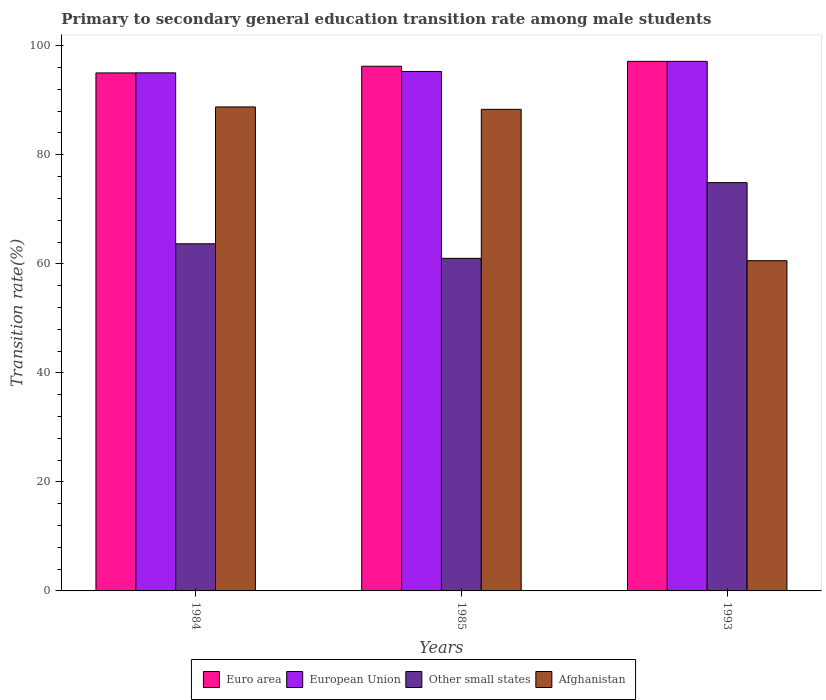How many groups of bars are there?
Your answer should be very brief. 3. In how many cases, is the number of bars for a given year not equal to the number of legend labels?
Your response must be concise. 0. What is the transition rate in Euro area in 1984?
Ensure brevity in your answer.  95.02. Across all years, what is the maximum transition rate in Other small states?
Offer a very short reply. 74.9. Across all years, what is the minimum transition rate in Euro area?
Ensure brevity in your answer.  95.02. In which year was the transition rate in Other small states maximum?
Offer a terse response. 1993. In which year was the transition rate in Other small states minimum?
Ensure brevity in your answer.  1985. What is the total transition rate in Afghanistan in the graph?
Give a very brief answer. 237.69. What is the difference between the transition rate in European Union in 1985 and that in 1993?
Provide a succinct answer. -1.85. What is the difference between the transition rate in Other small states in 1993 and the transition rate in European Union in 1984?
Make the answer very short. -20.14. What is the average transition rate in European Union per year?
Your answer should be compact. 95.82. In the year 1993, what is the difference between the transition rate in Afghanistan and transition rate in European Union?
Your answer should be compact. -36.57. What is the ratio of the transition rate in European Union in 1984 to that in 1993?
Keep it short and to the point. 0.98. Is the difference between the transition rate in Afghanistan in 1985 and 1993 greater than the difference between the transition rate in European Union in 1985 and 1993?
Provide a succinct answer. Yes. What is the difference between the highest and the second highest transition rate in Other small states?
Provide a short and direct response. 11.22. What is the difference between the highest and the lowest transition rate in Other small states?
Provide a short and direct response. 13.89. What does the 3rd bar from the left in 1984 represents?
Your answer should be very brief. Other small states. How many years are there in the graph?
Your response must be concise. 3. What is the difference between two consecutive major ticks on the Y-axis?
Offer a very short reply. 20. Does the graph contain any zero values?
Offer a terse response. No. What is the title of the graph?
Ensure brevity in your answer.  Primary to secondary general education transition rate among male students. What is the label or title of the Y-axis?
Provide a succinct answer. Transition rate(%). What is the Transition rate(%) of Euro area in 1984?
Give a very brief answer. 95.02. What is the Transition rate(%) in European Union in 1984?
Give a very brief answer. 95.03. What is the Transition rate(%) in Other small states in 1984?
Give a very brief answer. 63.68. What is the Transition rate(%) of Afghanistan in 1984?
Make the answer very short. 88.78. What is the Transition rate(%) of Euro area in 1985?
Provide a succinct answer. 96.24. What is the Transition rate(%) of European Union in 1985?
Keep it short and to the point. 95.29. What is the Transition rate(%) of Other small states in 1985?
Give a very brief answer. 61. What is the Transition rate(%) of Afghanistan in 1985?
Ensure brevity in your answer.  88.34. What is the Transition rate(%) of Euro area in 1993?
Your response must be concise. 97.14. What is the Transition rate(%) of European Union in 1993?
Your answer should be very brief. 97.14. What is the Transition rate(%) of Other small states in 1993?
Offer a terse response. 74.9. What is the Transition rate(%) of Afghanistan in 1993?
Offer a terse response. 60.58. Across all years, what is the maximum Transition rate(%) in Euro area?
Ensure brevity in your answer.  97.14. Across all years, what is the maximum Transition rate(%) in European Union?
Your response must be concise. 97.14. Across all years, what is the maximum Transition rate(%) in Other small states?
Your response must be concise. 74.9. Across all years, what is the maximum Transition rate(%) of Afghanistan?
Offer a terse response. 88.78. Across all years, what is the minimum Transition rate(%) in Euro area?
Your answer should be compact. 95.02. Across all years, what is the minimum Transition rate(%) of European Union?
Make the answer very short. 95.03. Across all years, what is the minimum Transition rate(%) in Other small states?
Make the answer very short. 61. Across all years, what is the minimum Transition rate(%) of Afghanistan?
Make the answer very short. 60.58. What is the total Transition rate(%) in Euro area in the graph?
Your answer should be compact. 288.4. What is the total Transition rate(%) of European Union in the graph?
Offer a very short reply. 287.46. What is the total Transition rate(%) in Other small states in the graph?
Ensure brevity in your answer.  199.58. What is the total Transition rate(%) in Afghanistan in the graph?
Offer a terse response. 237.69. What is the difference between the Transition rate(%) in Euro area in 1984 and that in 1985?
Provide a short and direct response. -1.22. What is the difference between the Transition rate(%) of European Union in 1984 and that in 1985?
Ensure brevity in your answer.  -0.25. What is the difference between the Transition rate(%) of Other small states in 1984 and that in 1985?
Offer a very short reply. 2.67. What is the difference between the Transition rate(%) in Afghanistan in 1984 and that in 1985?
Give a very brief answer. 0.44. What is the difference between the Transition rate(%) of Euro area in 1984 and that in 1993?
Provide a succinct answer. -2.12. What is the difference between the Transition rate(%) in European Union in 1984 and that in 1993?
Offer a very short reply. -2.11. What is the difference between the Transition rate(%) in Other small states in 1984 and that in 1993?
Provide a short and direct response. -11.22. What is the difference between the Transition rate(%) in Afghanistan in 1984 and that in 1993?
Keep it short and to the point. 28.2. What is the difference between the Transition rate(%) of Euro area in 1985 and that in 1993?
Give a very brief answer. -0.9. What is the difference between the Transition rate(%) of European Union in 1985 and that in 1993?
Your answer should be compact. -1.85. What is the difference between the Transition rate(%) in Other small states in 1985 and that in 1993?
Offer a very short reply. -13.89. What is the difference between the Transition rate(%) of Afghanistan in 1985 and that in 1993?
Ensure brevity in your answer.  27.76. What is the difference between the Transition rate(%) of Euro area in 1984 and the Transition rate(%) of European Union in 1985?
Your response must be concise. -0.27. What is the difference between the Transition rate(%) in Euro area in 1984 and the Transition rate(%) in Other small states in 1985?
Provide a short and direct response. 34.01. What is the difference between the Transition rate(%) of Euro area in 1984 and the Transition rate(%) of Afghanistan in 1985?
Offer a very short reply. 6.68. What is the difference between the Transition rate(%) of European Union in 1984 and the Transition rate(%) of Other small states in 1985?
Offer a terse response. 34.03. What is the difference between the Transition rate(%) in European Union in 1984 and the Transition rate(%) in Afghanistan in 1985?
Give a very brief answer. 6.69. What is the difference between the Transition rate(%) of Other small states in 1984 and the Transition rate(%) of Afghanistan in 1985?
Ensure brevity in your answer.  -24.66. What is the difference between the Transition rate(%) in Euro area in 1984 and the Transition rate(%) in European Union in 1993?
Provide a short and direct response. -2.12. What is the difference between the Transition rate(%) of Euro area in 1984 and the Transition rate(%) of Other small states in 1993?
Your answer should be compact. 20.12. What is the difference between the Transition rate(%) in Euro area in 1984 and the Transition rate(%) in Afghanistan in 1993?
Your response must be concise. 34.44. What is the difference between the Transition rate(%) of European Union in 1984 and the Transition rate(%) of Other small states in 1993?
Ensure brevity in your answer.  20.14. What is the difference between the Transition rate(%) in European Union in 1984 and the Transition rate(%) in Afghanistan in 1993?
Offer a very short reply. 34.46. What is the difference between the Transition rate(%) in Other small states in 1984 and the Transition rate(%) in Afghanistan in 1993?
Keep it short and to the point. 3.1. What is the difference between the Transition rate(%) of Euro area in 1985 and the Transition rate(%) of European Union in 1993?
Keep it short and to the point. -0.9. What is the difference between the Transition rate(%) in Euro area in 1985 and the Transition rate(%) in Other small states in 1993?
Provide a succinct answer. 21.34. What is the difference between the Transition rate(%) in Euro area in 1985 and the Transition rate(%) in Afghanistan in 1993?
Ensure brevity in your answer.  35.66. What is the difference between the Transition rate(%) of European Union in 1985 and the Transition rate(%) of Other small states in 1993?
Give a very brief answer. 20.39. What is the difference between the Transition rate(%) of European Union in 1985 and the Transition rate(%) of Afghanistan in 1993?
Offer a very short reply. 34.71. What is the difference between the Transition rate(%) of Other small states in 1985 and the Transition rate(%) of Afghanistan in 1993?
Your answer should be compact. 0.43. What is the average Transition rate(%) of Euro area per year?
Give a very brief answer. 96.13. What is the average Transition rate(%) in European Union per year?
Provide a short and direct response. 95.82. What is the average Transition rate(%) of Other small states per year?
Provide a succinct answer. 66.53. What is the average Transition rate(%) in Afghanistan per year?
Make the answer very short. 79.23. In the year 1984, what is the difference between the Transition rate(%) in Euro area and Transition rate(%) in European Union?
Keep it short and to the point. -0.01. In the year 1984, what is the difference between the Transition rate(%) in Euro area and Transition rate(%) in Other small states?
Provide a short and direct response. 31.34. In the year 1984, what is the difference between the Transition rate(%) of Euro area and Transition rate(%) of Afghanistan?
Offer a terse response. 6.24. In the year 1984, what is the difference between the Transition rate(%) in European Union and Transition rate(%) in Other small states?
Give a very brief answer. 31.36. In the year 1984, what is the difference between the Transition rate(%) of European Union and Transition rate(%) of Afghanistan?
Offer a terse response. 6.26. In the year 1984, what is the difference between the Transition rate(%) in Other small states and Transition rate(%) in Afghanistan?
Your answer should be very brief. -25.1. In the year 1985, what is the difference between the Transition rate(%) of Euro area and Transition rate(%) of European Union?
Offer a very short reply. 0.95. In the year 1985, what is the difference between the Transition rate(%) of Euro area and Transition rate(%) of Other small states?
Offer a terse response. 35.23. In the year 1985, what is the difference between the Transition rate(%) of Euro area and Transition rate(%) of Afghanistan?
Offer a very short reply. 7.9. In the year 1985, what is the difference between the Transition rate(%) in European Union and Transition rate(%) in Other small states?
Your answer should be very brief. 34.28. In the year 1985, what is the difference between the Transition rate(%) of European Union and Transition rate(%) of Afghanistan?
Your answer should be very brief. 6.95. In the year 1985, what is the difference between the Transition rate(%) in Other small states and Transition rate(%) in Afghanistan?
Your answer should be compact. -27.34. In the year 1993, what is the difference between the Transition rate(%) of Euro area and Transition rate(%) of European Union?
Offer a very short reply. -0. In the year 1993, what is the difference between the Transition rate(%) in Euro area and Transition rate(%) in Other small states?
Offer a terse response. 22.24. In the year 1993, what is the difference between the Transition rate(%) in Euro area and Transition rate(%) in Afghanistan?
Ensure brevity in your answer.  36.56. In the year 1993, what is the difference between the Transition rate(%) in European Union and Transition rate(%) in Other small states?
Offer a very short reply. 22.25. In the year 1993, what is the difference between the Transition rate(%) of European Union and Transition rate(%) of Afghanistan?
Provide a short and direct response. 36.57. In the year 1993, what is the difference between the Transition rate(%) of Other small states and Transition rate(%) of Afghanistan?
Provide a short and direct response. 14.32. What is the ratio of the Transition rate(%) of Euro area in 1984 to that in 1985?
Give a very brief answer. 0.99. What is the ratio of the Transition rate(%) in Other small states in 1984 to that in 1985?
Your response must be concise. 1.04. What is the ratio of the Transition rate(%) of Afghanistan in 1984 to that in 1985?
Keep it short and to the point. 1. What is the ratio of the Transition rate(%) in Euro area in 1984 to that in 1993?
Give a very brief answer. 0.98. What is the ratio of the Transition rate(%) in European Union in 1984 to that in 1993?
Provide a succinct answer. 0.98. What is the ratio of the Transition rate(%) in Other small states in 1984 to that in 1993?
Make the answer very short. 0.85. What is the ratio of the Transition rate(%) in Afghanistan in 1984 to that in 1993?
Make the answer very short. 1.47. What is the ratio of the Transition rate(%) in European Union in 1985 to that in 1993?
Your response must be concise. 0.98. What is the ratio of the Transition rate(%) in Other small states in 1985 to that in 1993?
Offer a terse response. 0.81. What is the ratio of the Transition rate(%) of Afghanistan in 1985 to that in 1993?
Provide a short and direct response. 1.46. What is the difference between the highest and the second highest Transition rate(%) of Euro area?
Make the answer very short. 0.9. What is the difference between the highest and the second highest Transition rate(%) of European Union?
Offer a terse response. 1.85. What is the difference between the highest and the second highest Transition rate(%) of Other small states?
Keep it short and to the point. 11.22. What is the difference between the highest and the second highest Transition rate(%) of Afghanistan?
Make the answer very short. 0.44. What is the difference between the highest and the lowest Transition rate(%) of Euro area?
Provide a short and direct response. 2.12. What is the difference between the highest and the lowest Transition rate(%) in European Union?
Provide a short and direct response. 2.11. What is the difference between the highest and the lowest Transition rate(%) of Other small states?
Ensure brevity in your answer.  13.89. What is the difference between the highest and the lowest Transition rate(%) of Afghanistan?
Ensure brevity in your answer.  28.2. 